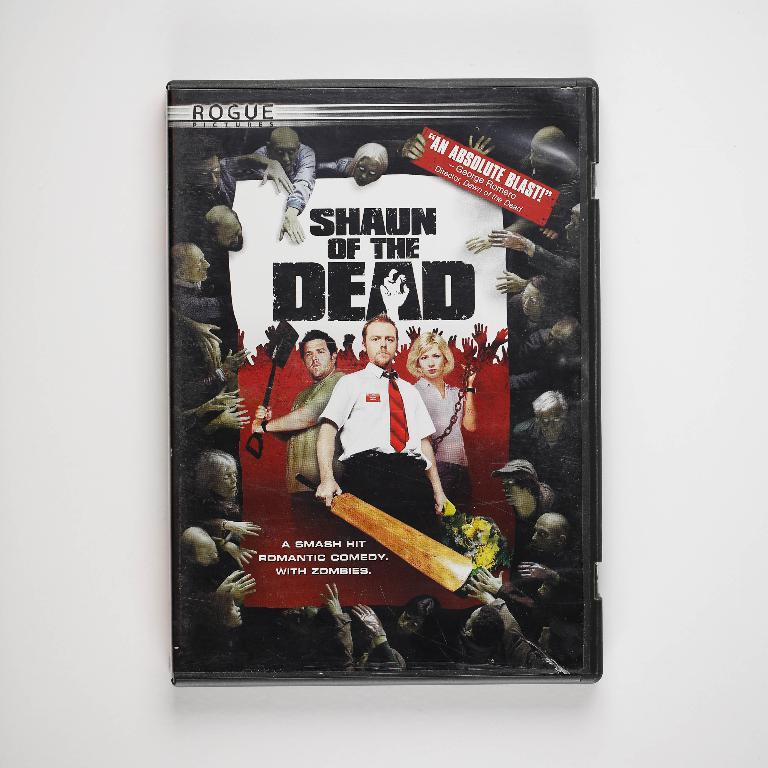<image>
Summarize the visual content of the image. It's a DVD copy of the movie "Shaun of the dead." 